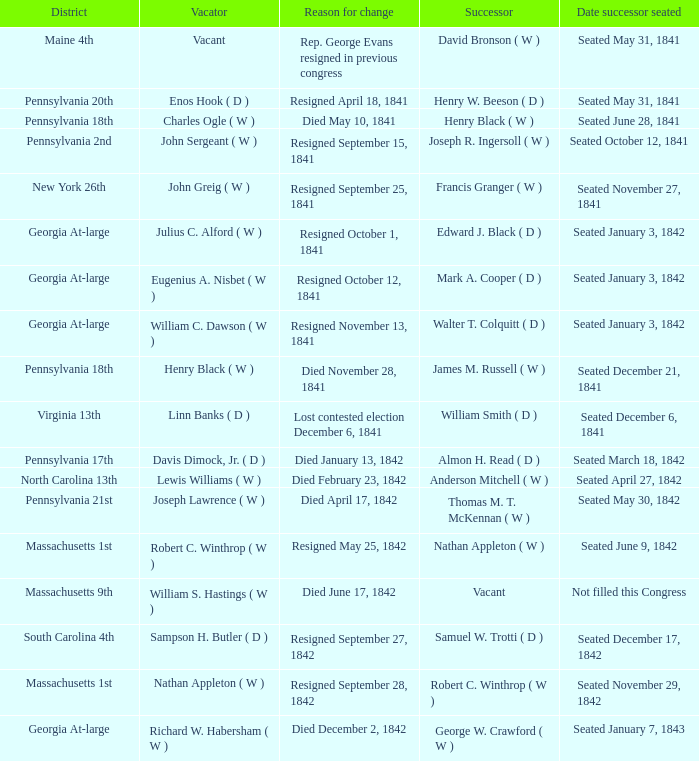Determine the date successor assumed position for pennsylvania's 17th. Seated March 18, 1842. 